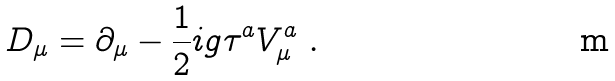<formula> <loc_0><loc_0><loc_500><loc_500>D _ { \mu } = \partial _ { \mu } - \frac { 1 } { 2 } i g \tau ^ { a } V _ { \mu } ^ { a } \ .</formula> 